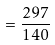<formula> <loc_0><loc_0><loc_500><loc_500>= \frac { 2 9 7 } { 1 4 0 }</formula> 